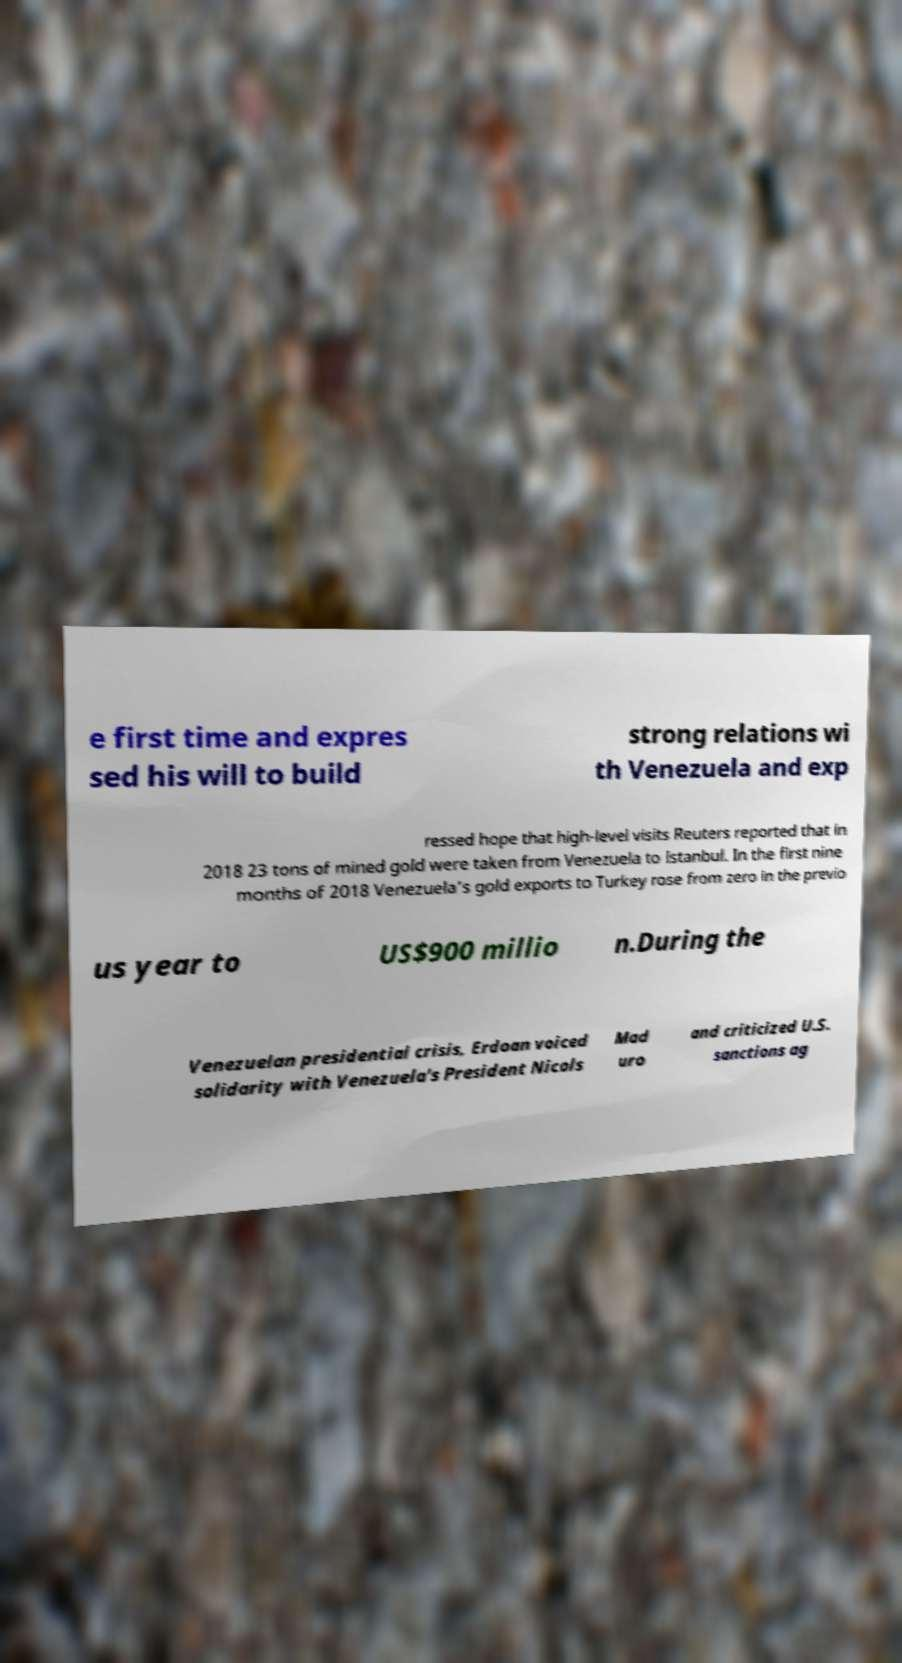Could you extract and type out the text from this image? e first time and expres sed his will to build strong relations wi th Venezuela and exp ressed hope that high-level visits Reuters reported that in 2018 23 tons of mined gold were taken from Venezuela to Istanbul. In the first nine months of 2018 Venezuela's gold exports to Turkey rose from zero in the previo us year to US$900 millio n.During the Venezuelan presidential crisis, Erdoan voiced solidarity with Venezuela's President Nicols Mad uro and criticized U.S. sanctions ag 